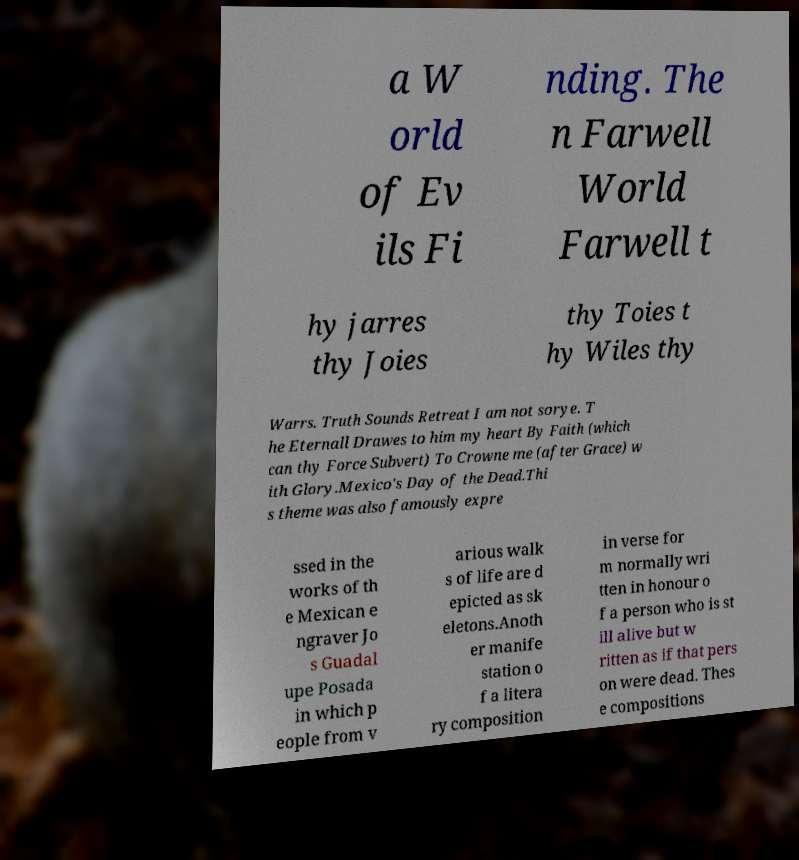I need the written content from this picture converted into text. Can you do that? a W orld of Ev ils Fi nding. The n Farwell World Farwell t hy jarres thy Joies thy Toies t hy Wiles thy Warrs. Truth Sounds Retreat I am not sorye. T he Eternall Drawes to him my heart By Faith (which can thy Force Subvert) To Crowne me (after Grace) w ith Glory.Mexico's Day of the Dead.Thi s theme was also famously expre ssed in the works of th e Mexican e ngraver Jo s Guadal upe Posada in which p eople from v arious walk s of life are d epicted as sk eletons.Anoth er manife station o f a litera ry composition in verse for m normally wri tten in honour o f a person who is st ill alive but w ritten as if that pers on were dead. Thes e compositions 